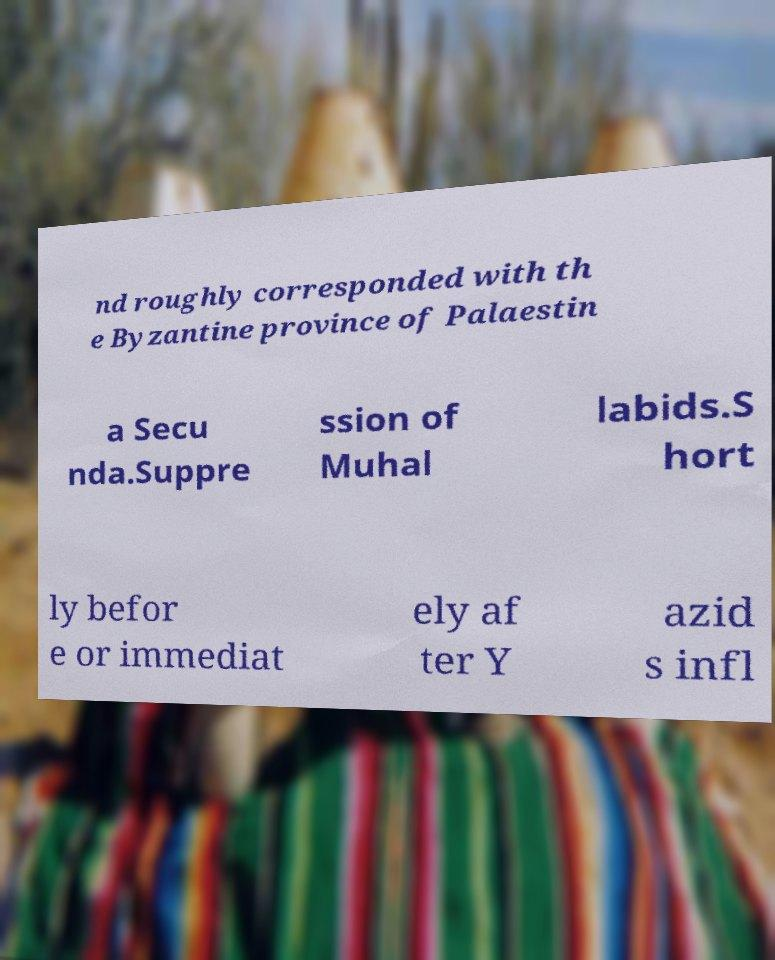Please read and relay the text visible in this image. What does it say? nd roughly corresponded with th e Byzantine province of Palaestin a Secu nda.Suppre ssion of Muhal labids.S hort ly befor e or immediat ely af ter Y azid s infl 